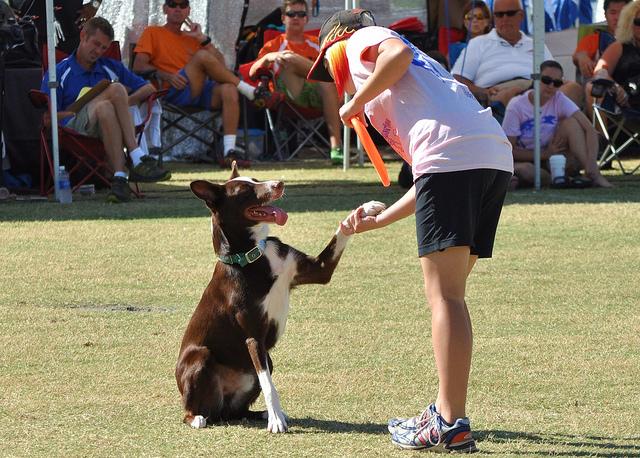Is the dog playing?
Be succinct. No. Is this a puppy?
Answer briefly. No. Can this puppy shake hands?
Concise answer only. Yes. Is that puppy talking?
Be succinct. No. 